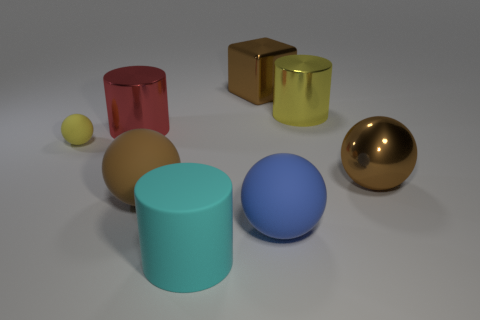Subtract 1 balls. How many balls are left? 3 Add 2 rubber things. How many objects exist? 10 Subtract all cubes. How many objects are left? 7 Subtract 0 cyan spheres. How many objects are left? 8 Subtract all cyan matte cylinders. Subtract all big things. How many objects are left? 0 Add 8 cyan objects. How many cyan objects are left? 9 Add 1 tiny purple balls. How many tiny purple balls exist? 1 